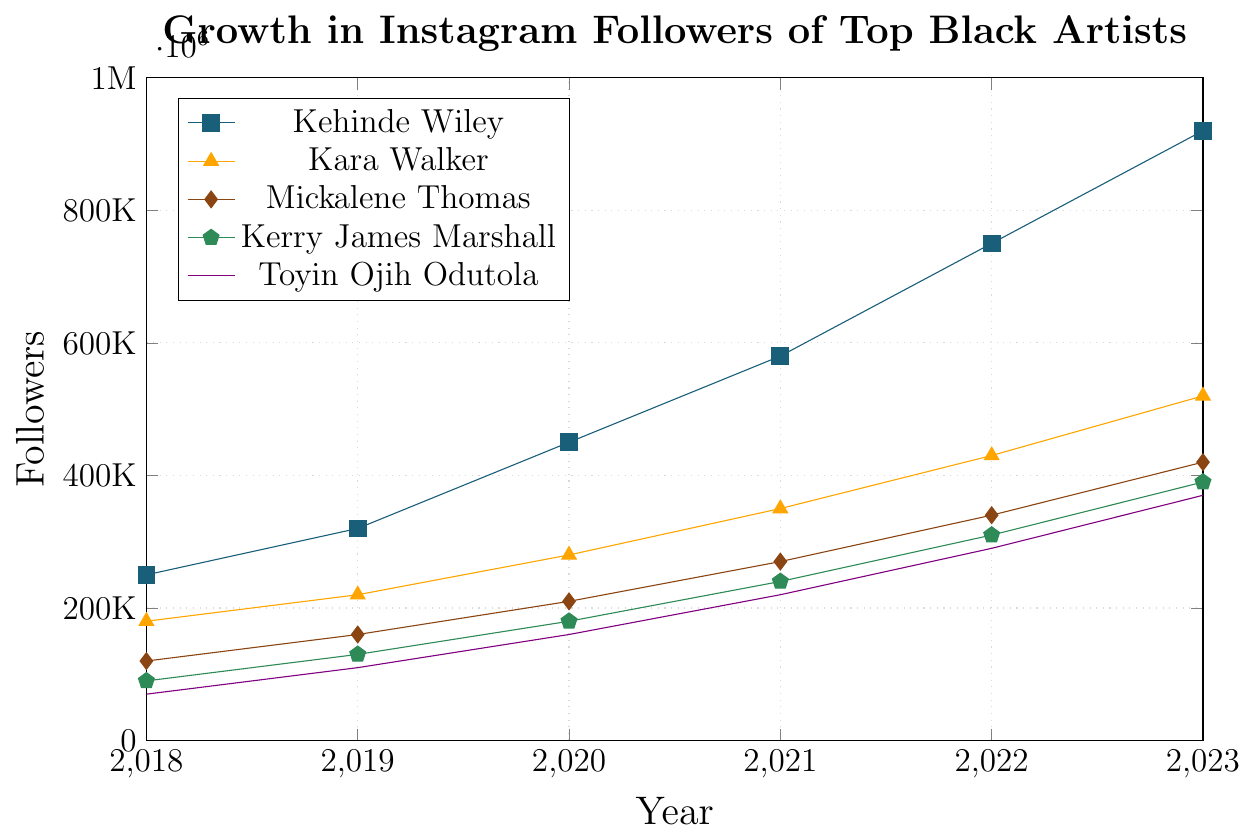How much did Kehinde Wiley's follower count increase from 2018 to 2023? To find the increase, we subtract the 2018 follower count from the 2023 follower count for Kehinde Wiley: 920,000 - 250,000 = 670,000
Answer: 670,000 Which artist had the smallest follower count in 2018? By comparing the follower counts in 2018 for each artist, we see that Toyin Ojih Odutola had the smallest count at 70,000
Answer: Toyin Ojih Odutola What is the difference in follower count between Kehinde Wiley and Kara Walker in 2023? Subtract Kara Walker's follower count in 2023 from Kehinde Wiley's follower count in 2023: 920,000 - 520,000 = 400,000
Answer: 400,000 Which artist had the fastest growth in followers from 2018 to 2023? To determine the fastest growth, we compare the differences in follower counts between 2018 and 2023 for all artists. Kehinde Wiley grew from 250,000 to 920,000, which is an increase of 670,000, the highest among the artists
Answer: Kehinde Wiley Who had more followers, Mickalene Thomas in 2021 or Kerry James Marshall in 2022? Comparing their follower counts: Mickalene Thomas had 270,000 followers in 2021, while Kerry James Marshall had 310,000 followers in 2022. 310,000 > 270,000
Answer: Kerry James Marshall Which artist had the closest follower count to 500,000 in 2023? In 2023, we compare the follower counts to 500,000. Kara Walker had 520,000 followers, which is the closest to 500,000 among the artists
Answer: Kara Walker What is the average follower count for Toyin Ojih Odutola from 2018 to 2023? Sum the follower counts from 2018 to 2023 for Toyin Ojih Odutola and divide by 6: (70,000 + 110,000 + 160,000 + 220,000 + 290,000 + 370,000) / 6 = 1,220,000 / 6 ≈ 203,333
Answer: 203,333 In what year did Kerry James Marshall surpass 300,000 followers? According to the data, Kerry James Marshall had 310,000 followers in 2022, which is the first year his count surpassed 300,000
Answer: 2022 How much did Mickalene Thomas's follower count increase between 2019 and 2020? Subtract the follower count in 2019 from the count in 2020 for Mickalene Thomas: 210,000 - 160,000 = 50,000
Answer: 50,000 Which artist had the largest single-year growth in the entire period, and in which year? Reviewing the dataset, Kehinde Wiley had the largest single-year growth from 2021 to 2022, increasing by 750,000 - 580,000 = 170,000
Answer: Kehinde Wiley, 2022 